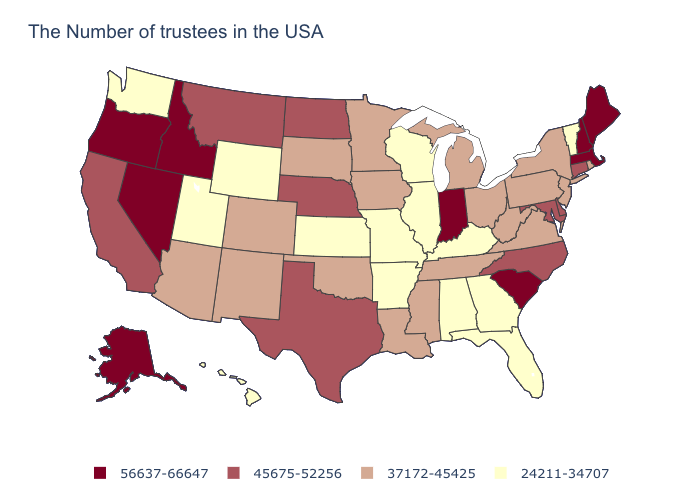Which states have the lowest value in the Northeast?
Quick response, please. Vermont. Is the legend a continuous bar?
Keep it brief. No. Which states have the lowest value in the USA?
Keep it brief. Vermont, Florida, Georgia, Kentucky, Alabama, Wisconsin, Illinois, Missouri, Arkansas, Kansas, Wyoming, Utah, Washington, Hawaii. Which states hav the highest value in the Northeast?
Be succinct. Maine, Massachusetts, New Hampshire. Among the states that border Wyoming , which have the highest value?
Answer briefly. Idaho. Name the states that have a value in the range 24211-34707?
Short answer required. Vermont, Florida, Georgia, Kentucky, Alabama, Wisconsin, Illinois, Missouri, Arkansas, Kansas, Wyoming, Utah, Washington, Hawaii. Name the states that have a value in the range 56637-66647?
Short answer required. Maine, Massachusetts, New Hampshire, South Carolina, Indiana, Idaho, Nevada, Oregon, Alaska. Which states have the lowest value in the Northeast?
Concise answer only. Vermont. What is the lowest value in the Northeast?
Give a very brief answer. 24211-34707. Name the states that have a value in the range 56637-66647?
Be succinct. Maine, Massachusetts, New Hampshire, South Carolina, Indiana, Idaho, Nevada, Oregon, Alaska. Is the legend a continuous bar?
Quick response, please. No. Does the first symbol in the legend represent the smallest category?
Give a very brief answer. No. How many symbols are there in the legend?
Answer briefly. 4. Name the states that have a value in the range 45675-52256?
Concise answer only. Connecticut, Delaware, Maryland, North Carolina, Nebraska, Texas, North Dakota, Montana, California. Among the states that border Utah , does Wyoming have the lowest value?
Concise answer only. Yes. 